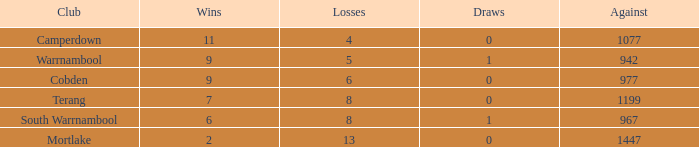How many successes did cobden obtain when draws exceeded 0? 0.0. 